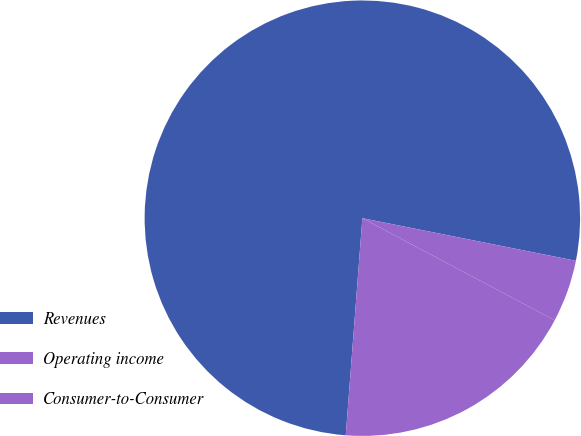Convert chart to OTSL. <chart><loc_0><loc_0><loc_500><loc_500><pie_chart><fcel>Revenues<fcel>Operating income<fcel>Consumer-to-Consumer<nl><fcel>76.92%<fcel>18.45%<fcel>4.63%<nl></chart> 